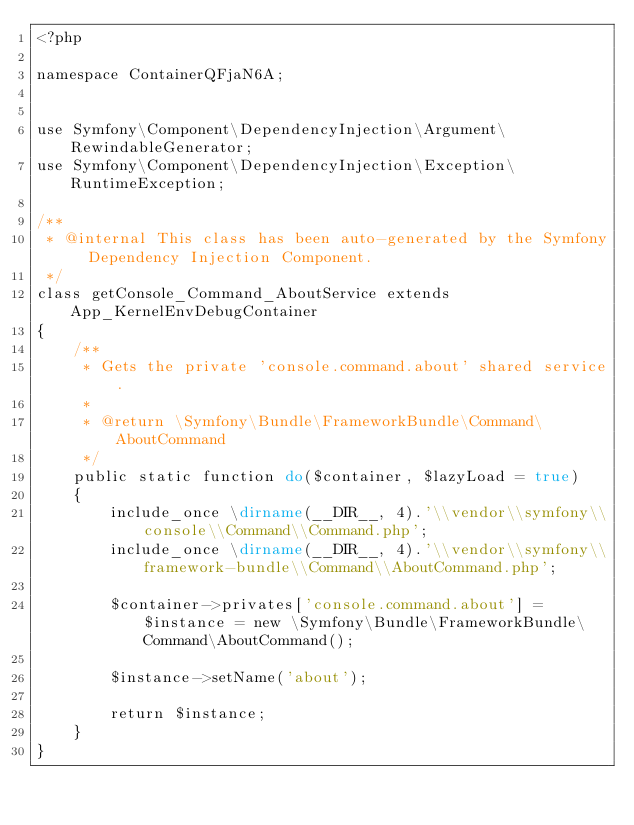<code> <loc_0><loc_0><loc_500><loc_500><_PHP_><?php

namespace ContainerQFjaN6A;


use Symfony\Component\DependencyInjection\Argument\RewindableGenerator;
use Symfony\Component\DependencyInjection\Exception\RuntimeException;

/**
 * @internal This class has been auto-generated by the Symfony Dependency Injection Component.
 */
class getConsole_Command_AboutService extends App_KernelEnvDebugContainer
{
    /**
     * Gets the private 'console.command.about' shared service.
     *
     * @return \Symfony\Bundle\FrameworkBundle\Command\AboutCommand
     */
    public static function do($container, $lazyLoad = true)
    {
        include_once \dirname(__DIR__, 4).'\\vendor\\symfony\\console\\Command\\Command.php';
        include_once \dirname(__DIR__, 4).'\\vendor\\symfony\\framework-bundle\\Command\\AboutCommand.php';

        $container->privates['console.command.about'] = $instance = new \Symfony\Bundle\FrameworkBundle\Command\AboutCommand();

        $instance->setName('about');

        return $instance;
    }
}
</code> 